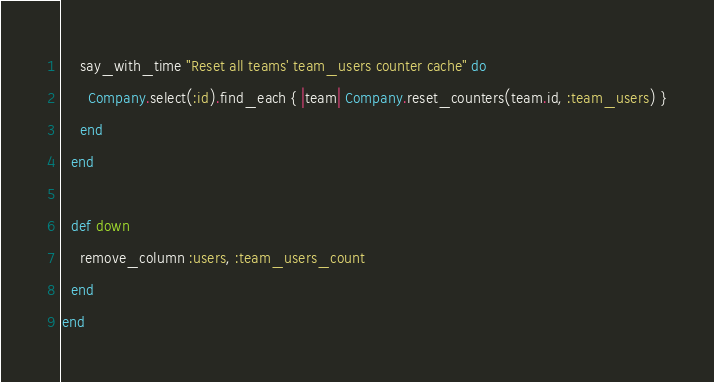<code> <loc_0><loc_0><loc_500><loc_500><_Ruby_>    say_with_time "Reset all teams' team_users counter cache" do
      Company.select(:id).find_each { |team| Company.reset_counters(team.id, :team_users) }
    end
  end

  def down
    remove_column :users, :team_users_count
  end
end
</code> 